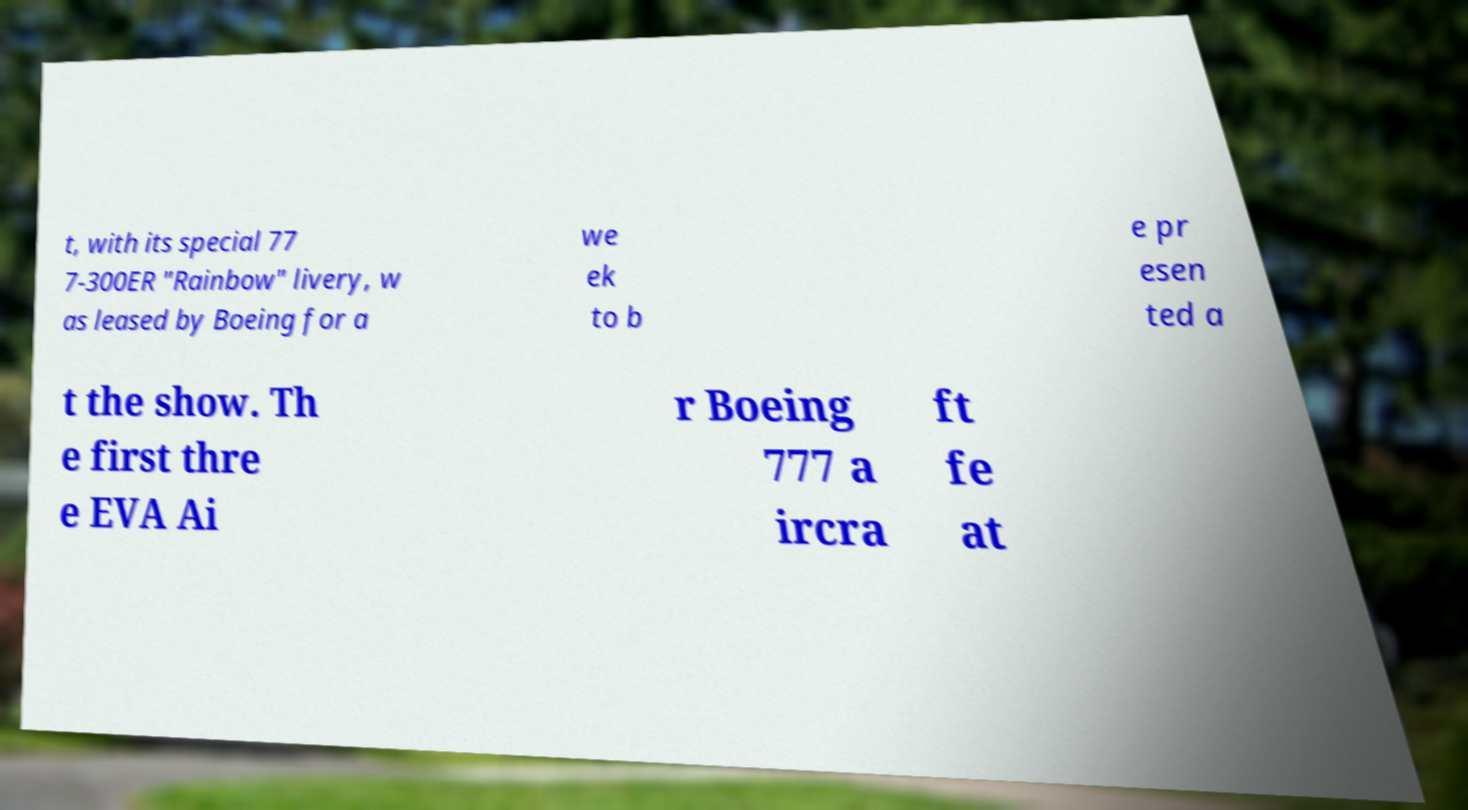I need the written content from this picture converted into text. Can you do that? t, with its special 77 7-300ER "Rainbow" livery, w as leased by Boeing for a we ek to b e pr esen ted a t the show. Th e first thre e EVA Ai r Boeing 777 a ircra ft fe at 